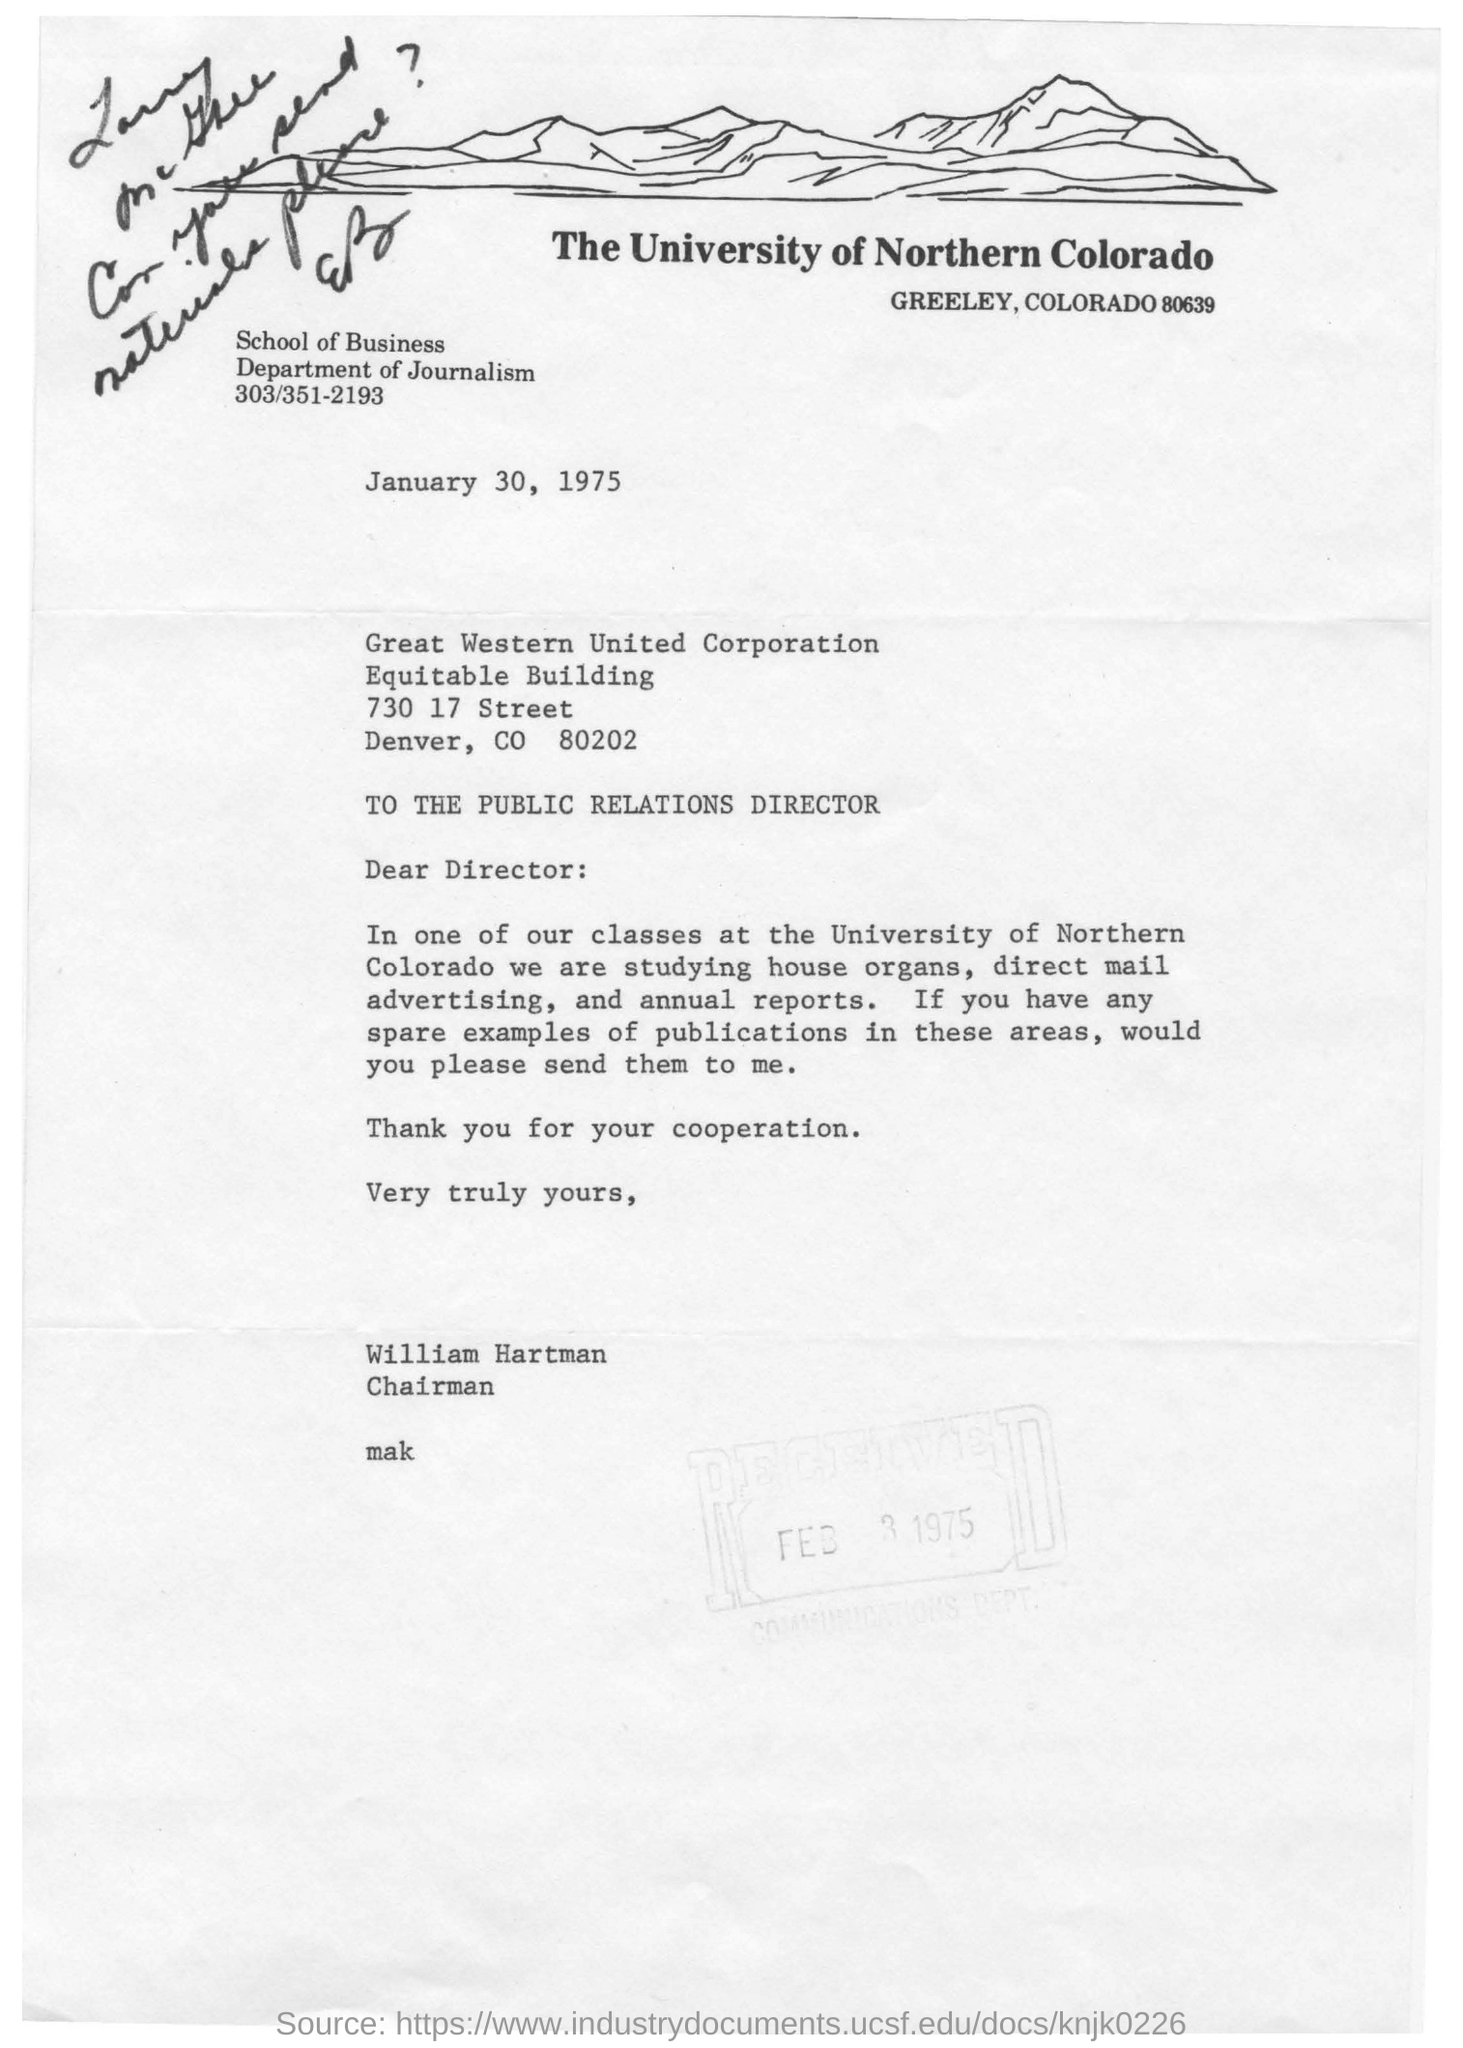Highlight a few significant elements in this photo. The letter was sent by William Hartman. Who is the letter addressed to? The letter is addressed to the Director. The University of Northern Colorado is mentioned in the letterhead. William Hartman is the Chairman. The date mentioned in this letter is January 30, 1975. 